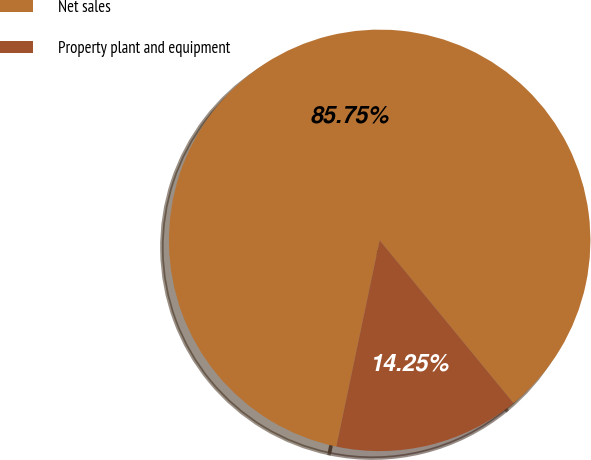Convert chart. <chart><loc_0><loc_0><loc_500><loc_500><pie_chart><fcel>Net sales<fcel>Property plant and equipment<nl><fcel>85.75%<fcel>14.25%<nl></chart> 